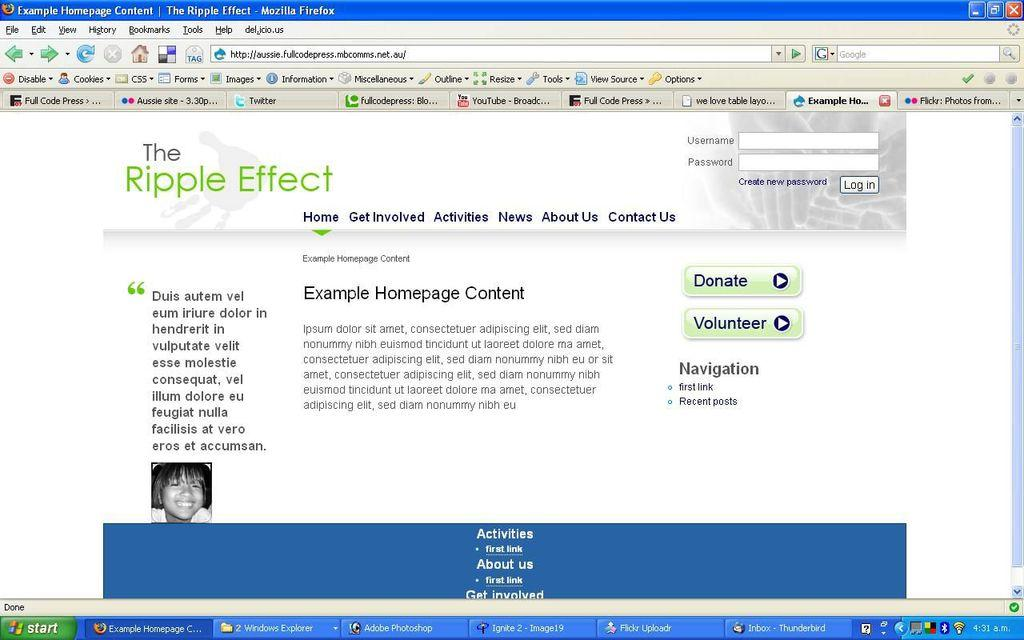<image>
Offer a succinct explanation of the picture presented. Computer screen showing The Ripple Effect as well as a picture of a woman. 